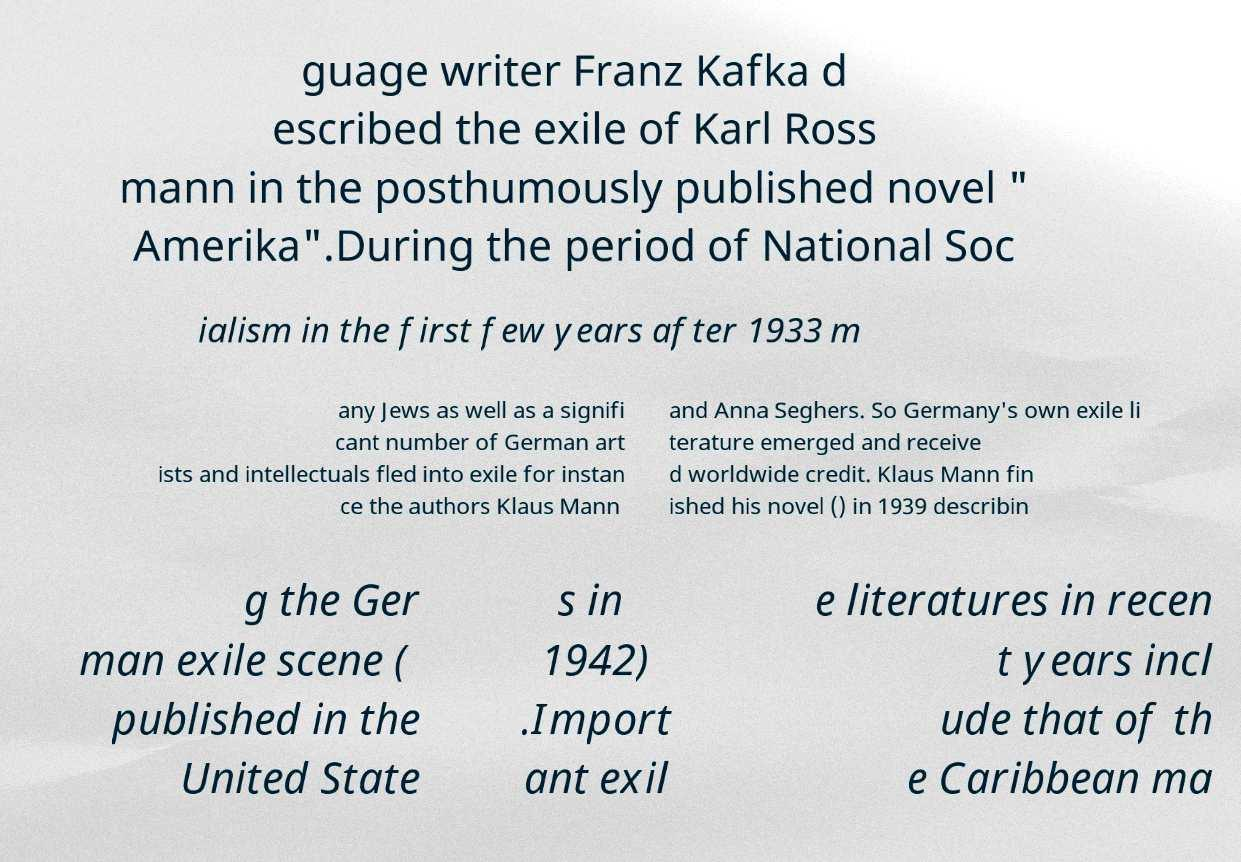For documentation purposes, I need the text within this image transcribed. Could you provide that? guage writer Franz Kafka d escribed the exile of Karl Ross mann in the posthumously published novel " Amerika".During the period of National Soc ialism in the first few years after 1933 m any Jews as well as a signifi cant number of German art ists and intellectuals fled into exile for instan ce the authors Klaus Mann and Anna Seghers. So Germany's own exile li terature emerged and receive d worldwide credit. Klaus Mann fin ished his novel () in 1939 describin g the Ger man exile scene ( published in the United State s in 1942) .Import ant exil e literatures in recen t years incl ude that of th e Caribbean ma 